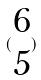Convert formula to latex. <formula><loc_0><loc_0><loc_500><loc_500>( \begin{matrix} 6 \\ 5 \end{matrix} )</formula> 